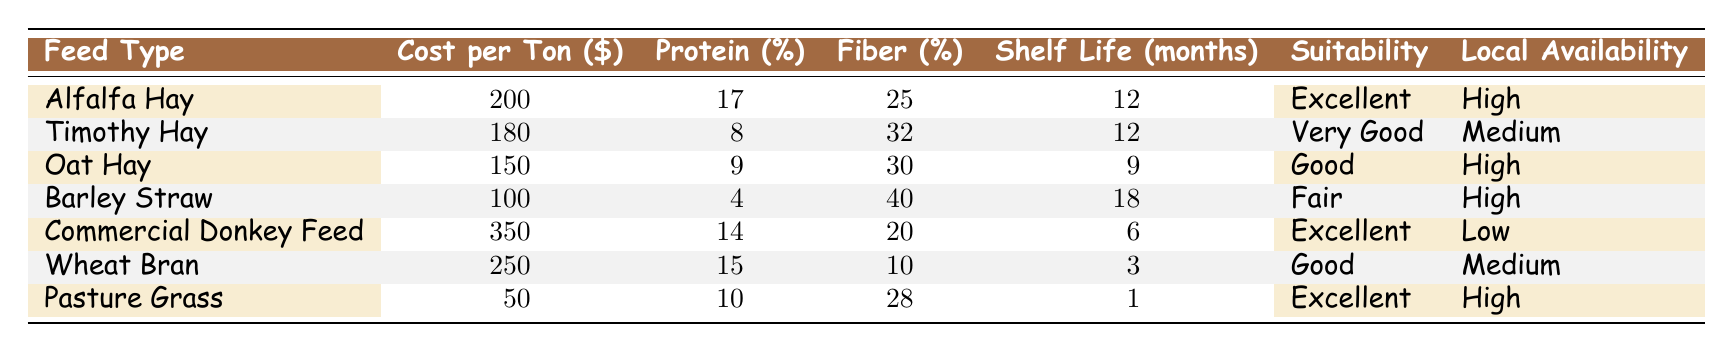What's the cost per ton of Alfalfa Hay? From the table, in the row for Alfalfa Hay, the cost per ton is directly listed as 200 dollars.
Answer: 200 Which feed type has the highest protein content? Looking through the Protein Content column, Alfalfa Hay has the highest percentage at 17%.
Answer: Alfalfa Hay Is the local availability of Commercial Donkey Feed high? The table states that the local availability for Commercial Donkey Feed is low. Therefore, this statement is false.
Answer: No What is the average cost per ton of the different types of hay (Alfalfa Hay, Timothy Hay, Oat Hay, and Barley Straw)? First, we identify the costs: 200 (Alfalfa) + 180 (Timothy) + 150 (Oat) + 100 (Barley) = 630. There are 4 types of hay, so we divide 630 by 4. Therefore, the average cost per ton is 630/4 = 157.5.
Answer: 157.5 Which feed type has the shortest shelf life, and what is that shelf life? By examining the Shelf Life column, Wheat Bran has the shortest shelf life at 3 months.
Answer: Wheat Bran, 3 months Are both Oat Hay and Barley Straw suitable for donkeys? Oat Hay is marked as "Good" and Barley Straw is marked as "Fair" in the suitability column, indicating both are suitable but Barley Straw is less suitable. Therefore, the answer is yes; they are both suitable to some extent.
Answer: Yes What is the difference in protein content between the highest and lowest protein feed types? The highest protein content is from Alfalfa Hay at 17%, while the lowest is from Barley Straw at 4%. The difference is calculated as 17 - 4 = 13.
Answer: 13 Which feed type has the longest shelf life and what is that duration? In the Shelf Life column, Barley Straw has the longest duration at 18 months.
Answer: Barley Straw, 18 months How many feed types have "Excellent" suitability for donkeys? By reviewing the Suitability column, Alfalfa Hay, Commercial Donkey Feed, and Pasture Grass are marked as "Excellent", totaling 3 types.
Answer: 3 